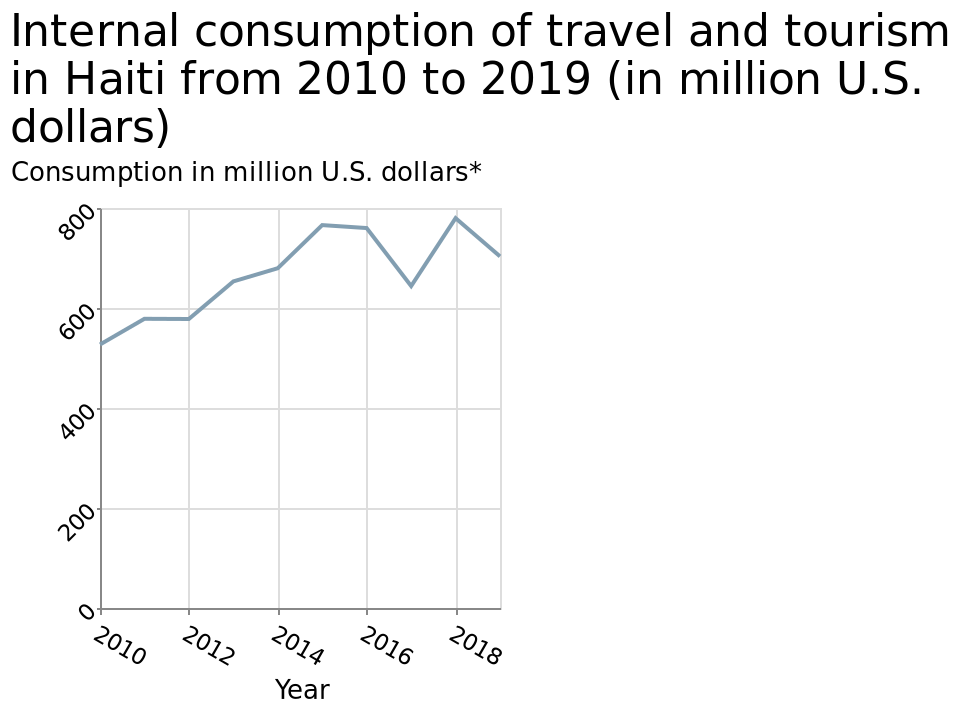<image>
What was the approximate internal travel and tourism revenue in 2010?  The approximate internal travel and tourism revenue in 2010 was around $550m. please enumerates aspects of the construction of the chart This line diagram is called Internal consumption of travel and tourism in Haiti from 2010 to 2019 (in million U.S. dollars). Consumption in million U.S. dollars* is defined with a linear scale with a minimum of 0 and a maximum of 800 on the y-axis. The x-axis plots Year. What was the percentage increase in internal travel and tourism revenue between 2010 and 2018? The internal travel and tourism revenue increased by approximately 44% between 2010 and 2018, from $550m to around $790m. please summary the statistics and relations of the chart Between 2010 and 2019 there has been a significant increase in internal travel and tourism. It increased from circa $550m in 2010 to a peal of circa $790m in 2018. It has since dropped a little but remains much higher than 2010. What does the x-axis represent on the line diagram? The x-axis on the line diagram represents the years from 2010 to 2019. What is the title of the line diagram? The title of the line diagram is "Internal consumption of travel and tourism in Haiti from 2010 to 2019 (in million U.S. dollars)." Is this pie chart called External consumption of travel and tourism in Haiti from 2010 to 2019 (in million U.S. dollars)? No.This line diagram is called Internal consumption of travel and tourism in Haiti from 2010 to 2019 (in million U.S. dollars). Consumption in million U.S. dollars* is defined with a linear scale with a minimum of 0 and a maximum of 800 on the y-axis. The x-axis plots Year. 